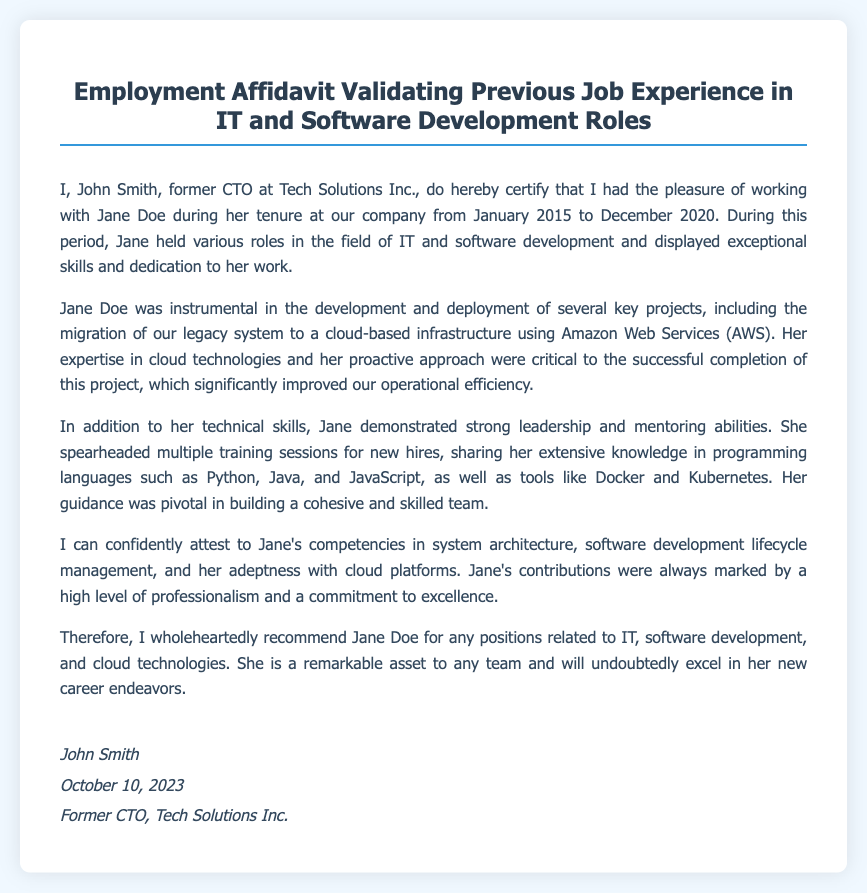What is the name of the person certifying the affidavit? The name of the person certifying the affidavit is mentioned in the document as John Smith.
Answer: John Smith What was Jane Doe's role at Tech Solutions Inc.? The document specifies that Jane Doe held various roles in the field of IT and software development during her tenure at Tech Solutions Inc.
Answer: Various roles in IT and software development What technology did Jane Doe work with for the migration project? The affidavit states that Jane Doe was involved in the migration of a legacy system to a cloud-based infrastructure using Amazon Web Services (AWS).
Answer: Amazon Web Services How long did Jane Doe work at Tech Solutions Inc.? The duration of Jane Doe's employment at Tech Solutions Inc. is indicated as from January 2015 to December 2020, which totals to five years.
Answer: Five years What skills did Jane Doe share during training sessions? The document notes that Jane Doe shared her extensive knowledge in programming languages such as Python, Java, and JavaScript, as well as tools like Docker and Kubernetes.
Answer: Python, Java, JavaScript, Docker, Kubernetes Why is Jane Doe recommended for IT positions? Jane Doe is recommended for positions related to IT and software development due to her competencies in system architecture, software development lifecycle management, and adeptness with cloud platforms.
Answer: Competencies in system architecture, software development lifecycle management, and cloud platforms When was the affidavit signed? The document includes the signing date, which is specified as October 10, 2023.
Answer: October 10, 2023 What is John Smith's title? The affidavit identifies John Smith's title as Former CTO at Tech Solutions Inc.
Answer: Former CTO 